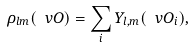Convert formula to latex. <formula><loc_0><loc_0><loc_500><loc_500>\rho _ { l m } ( \ v O ) = \sum _ { i } Y _ { l , m } ( \ v O _ { i } ) ,</formula> 